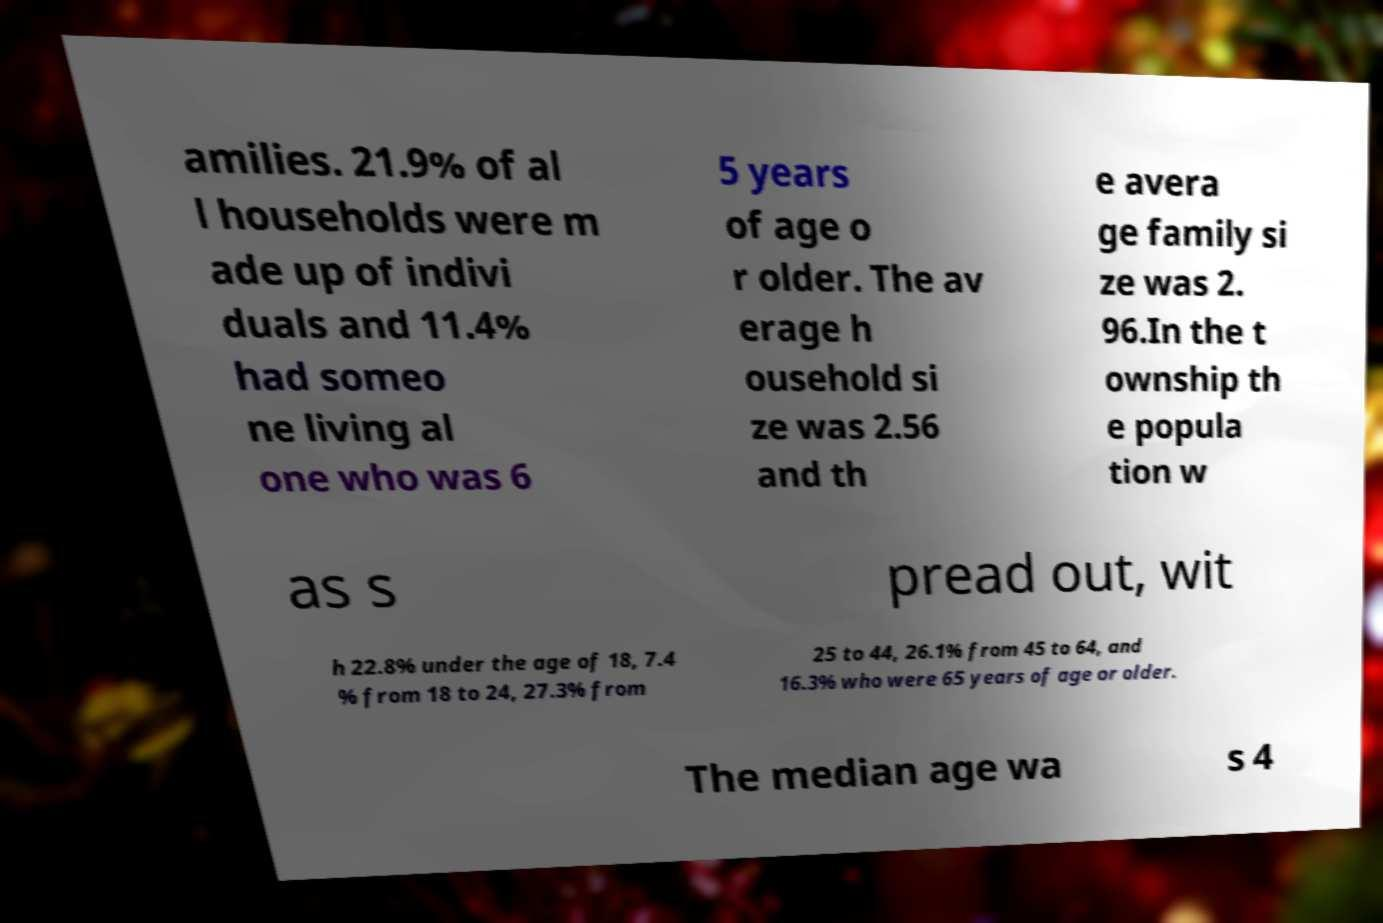Please identify and transcribe the text found in this image. amilies. 21.9% of al l households were m ade up of indivi duals and 11.4% had someo ne living al one who was 6 5 years of age o r older. The av erage h ousehold si ze was 2.56 and th e avera ge family si ze was 2. 96.In the t ownship th e popula tion w as s pread out, wit h 22.8% under the age of 18, 7.4 % from 18 to 24, 27.3% from 25 to 44, 26.1% from 45 to 64, and 16.3% who were 65 years of age or older. The median age wa s 4 